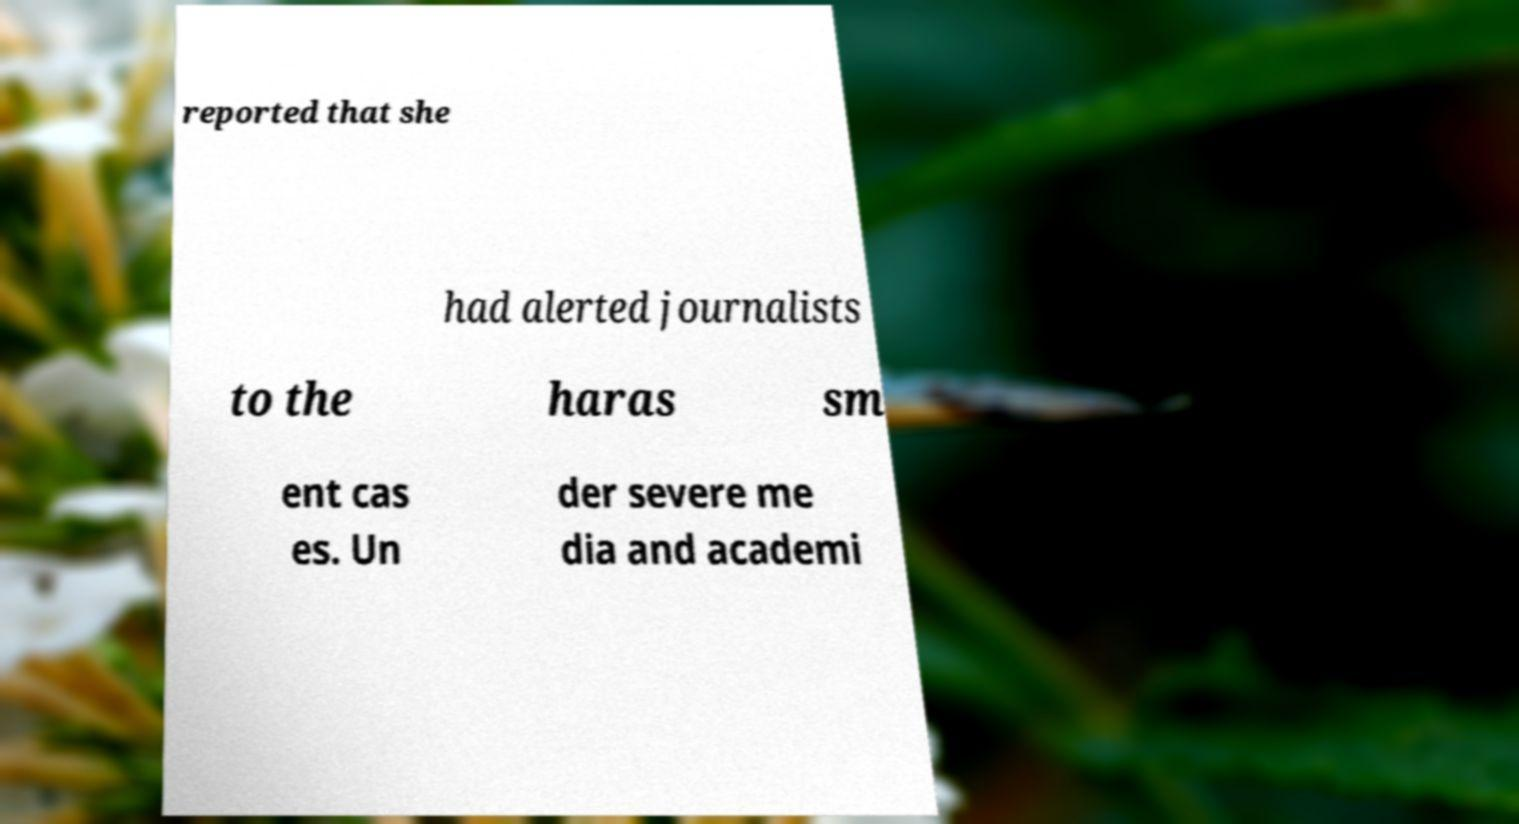Can you read and provide the text displayed in the image?This photo seems to have some interesting text. Can you extract and type it out for me? reported that she had alerted journalists to the haras sm ent cas es. Un der severe me dia and academi 